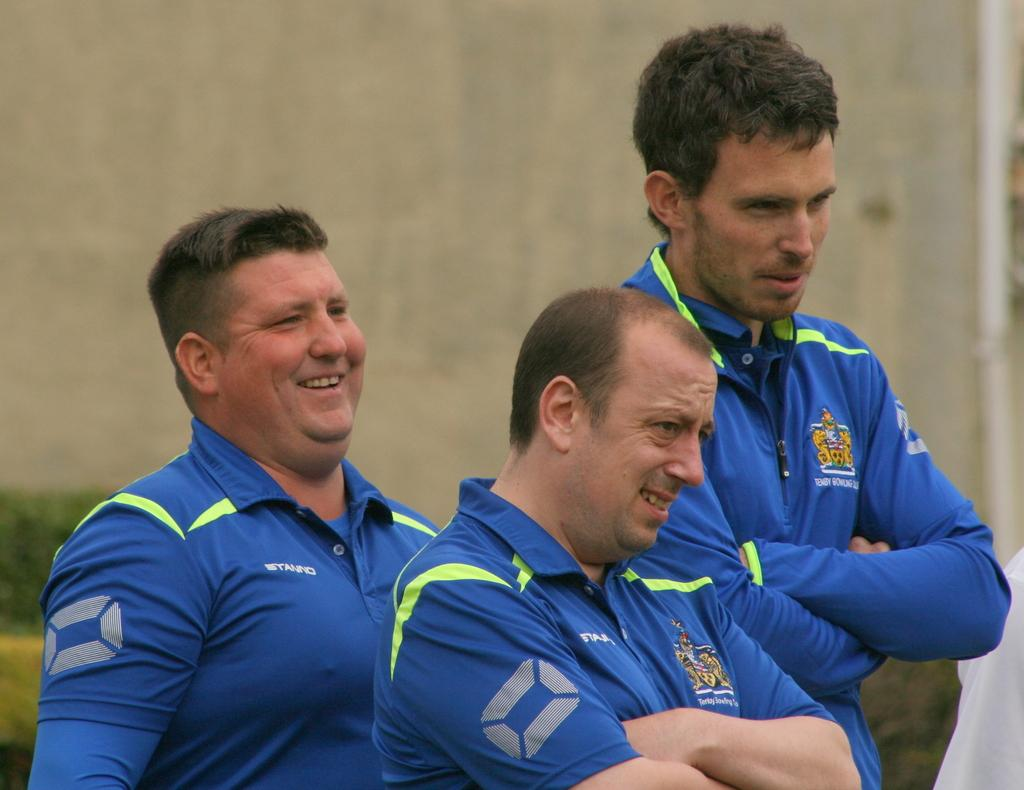How many people are in the image? There are three men in the image. What expressions do the men have in the image? The men are smiling in the image. What can be seen in the background of the image? There is a wall and plants in the background of the image. How would you describe the background of the image? The background is blurry in the image. What type of hope can be seen hanging from the wall in the image? There is no hope present in the image, and therefore no such object can be observed. 